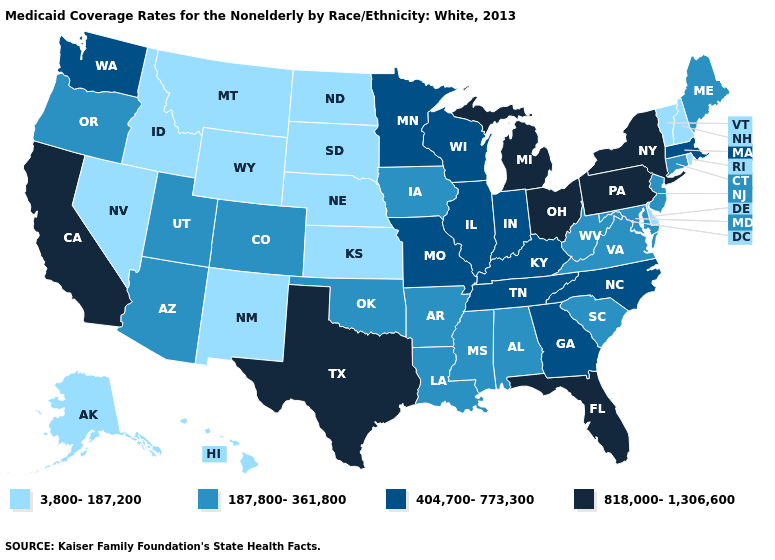What is the value of Rhode Island?
Concise answer only. 3,800-187,200. Does the first symbol in the legend represent the smallest category?
Quick response, please. Yes. What is the value of Kentucky?
Give a very brief answer. 404,700-773,300. Does Pennsylvania have the same value as Connecticut?
Keep it brief. No. Does the map have missing data?
Short answer required. No. What is the lowest value in the USA?
Answer briefly. 3,800-187,200. Does New Mexico have the lowest value in the West?
Write a very short answer. Yes. What is the lowest value in states that border California?
Be succinct. 3,800-187,200. How many symbols are there in the legend?
Quick response, please. 4. Among the states that border Missouri , which have the lowest value?
Answer briefly. Kansas, Nebraska. Name the states that have a value in the range 404,700-773,300?
Keep it brief. Georgia, Illinois, Indiana, Kentucky, Massachusetts, Minnesota, Missouri, North Carolina, Tennessee, Washington, Wisconsin. Is the legend a continuous bar?
Be succinct. No. Is the legend a continuous bar?
Give a very brief answer. No. Does Ohio have the highest value in the USA?
Write a very short answer. Yes. What is the value of Arkansas?
Quick response, please. 187,800-361,800. 